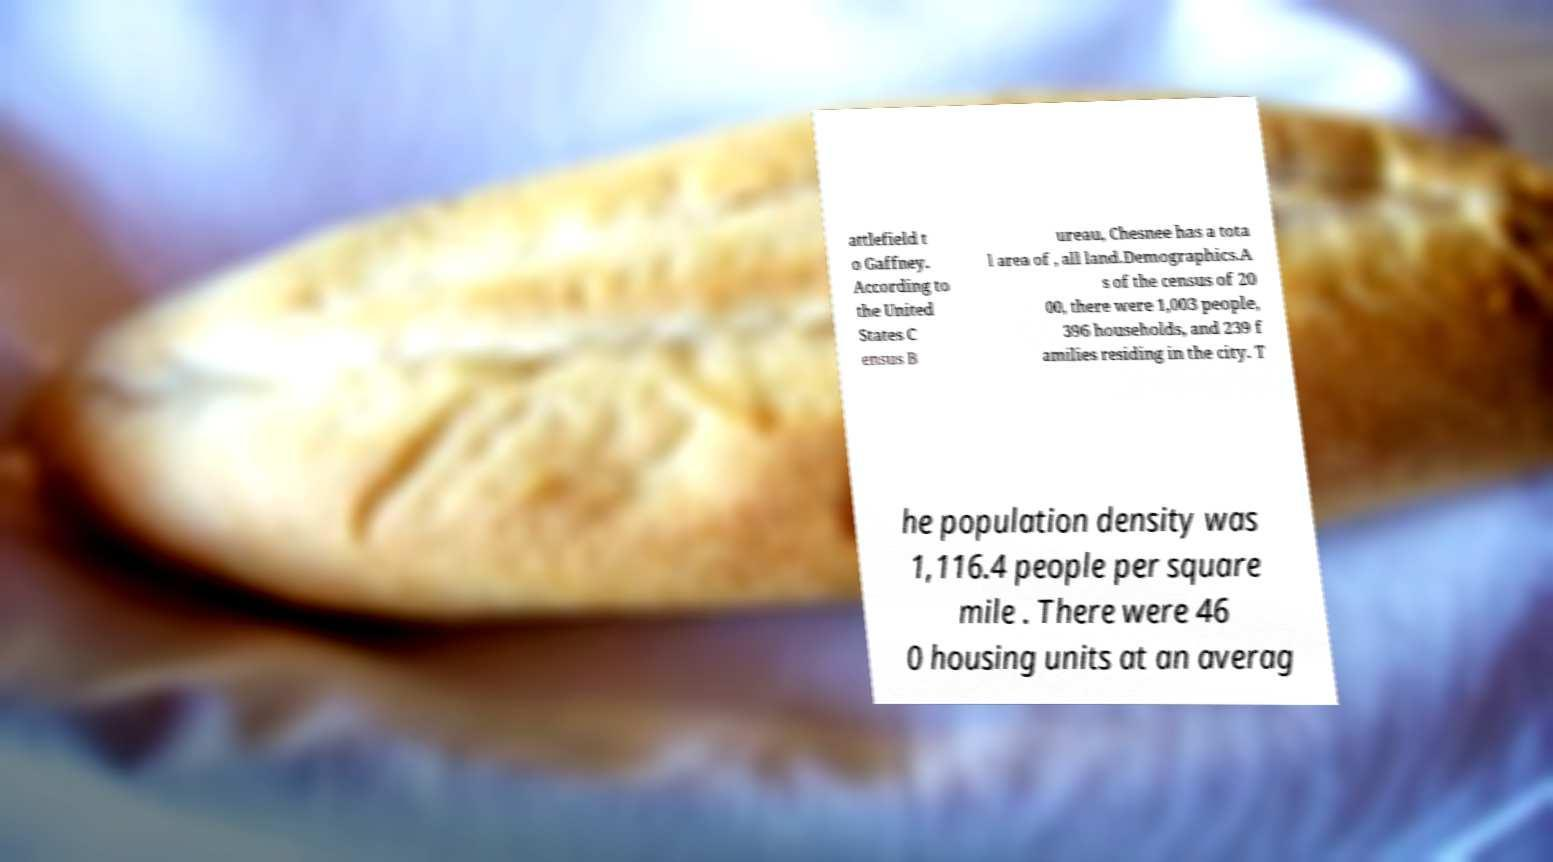Could you assist in decoding the text presented in this image and type it out clearly? attlefield t o Gaffney. According to the United States C ensus B ureau, Chesnee has a tota l area of , all land.Demographics.A s of the census of 20 00, there were 1,003 people, 396 households, and 239 f amilies residing in the city. T he population density was 1,116.4 people per square mile . There were 46 0 housing units at an averag 